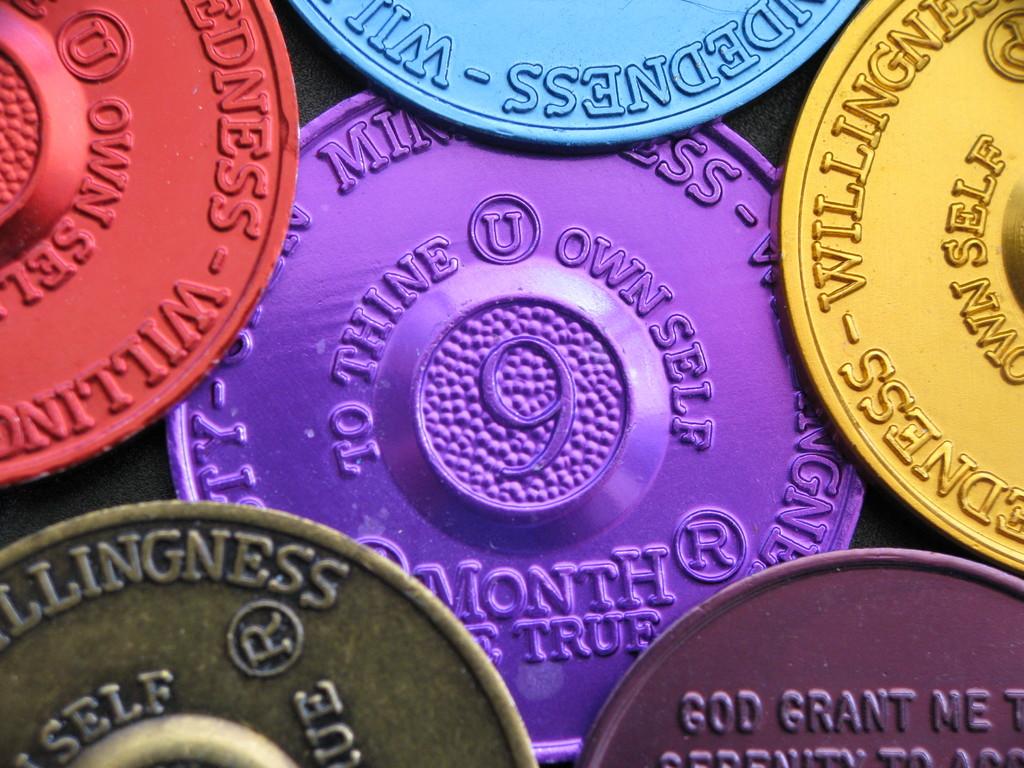What letter is inside the circle on each coin?
Ensure brevity in your answer.  U, r. What words wrap around the number 9?
Ensure brevity in your answer.  To thine own self. 